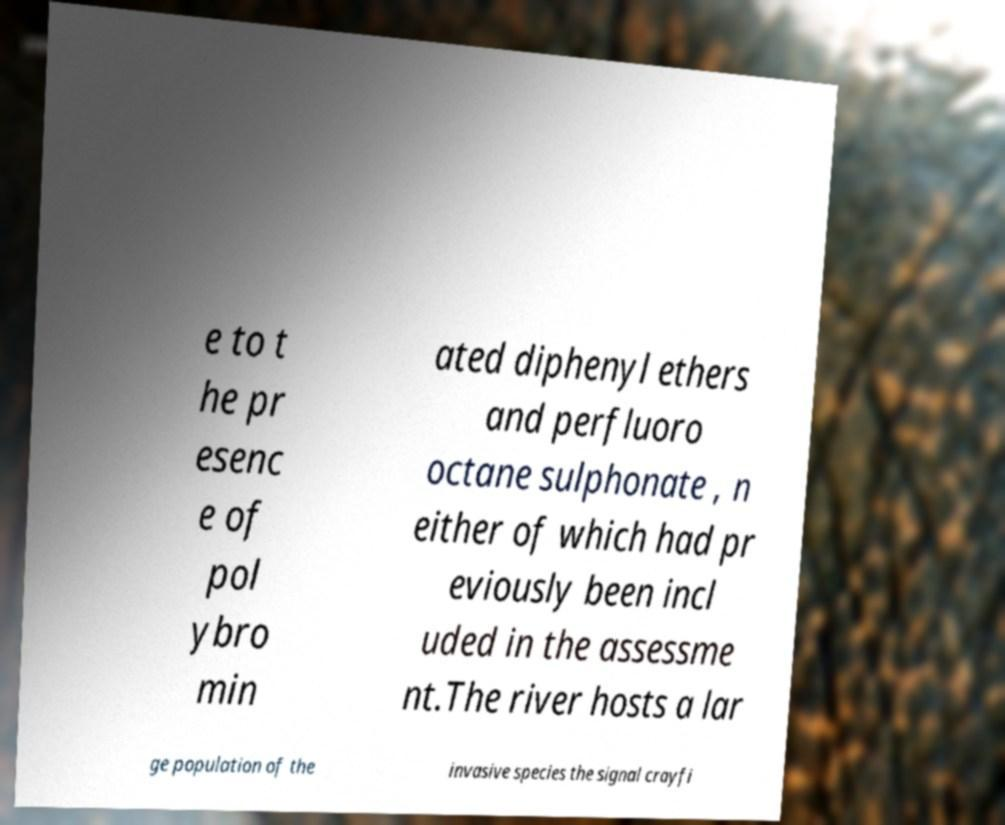Please read and relay the text visible in this image. What does it say? e to t he pr esenc e of pol ybro min ated diphenyl ethers and perfluoro octane sulphonate , n either of which had pr eviously been incl uded in the assessme nt.The river hosts a lar ge population of the invasive species the signal crayfi 